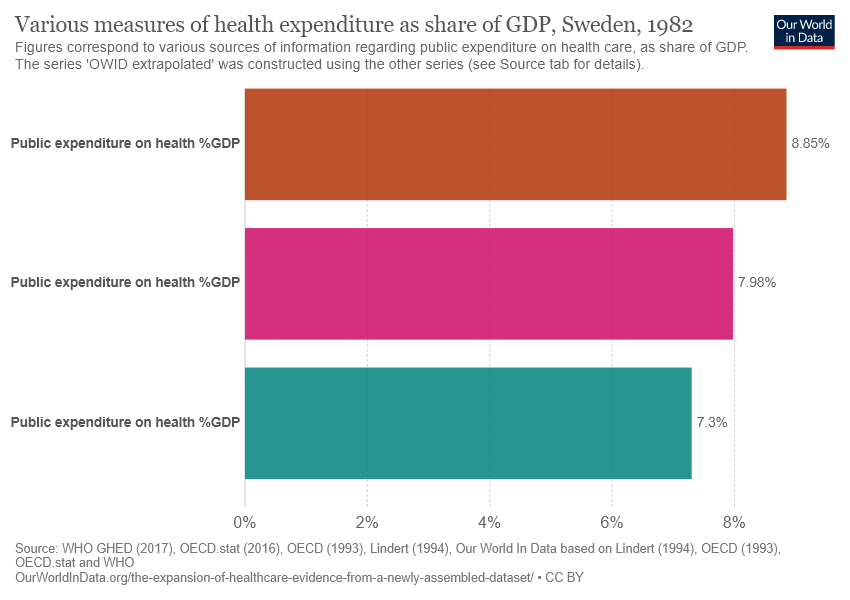Specify some key components in this picture. There are three color bars shown in the chart. The average of all three bars is approximately 8.043. 